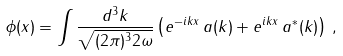Convert formula to latex. <formula><loc_0><loc_0><loc_500><loc_500>\phi ( x ) = \int { \frac { d ^ { 3 } k } { \sqrt { ( 2 \pi ) ^ { 3 } 2 \omega } } } \left ( e ^ { - i k x } \, a ( { k } ) + e ^ { i k x } \, a ^ { * } ( { k } ) \right ) \, ,</formula> 